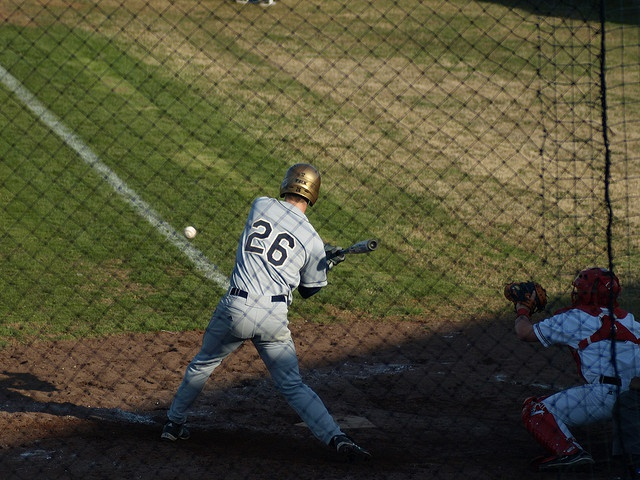Describe the objects in this image and their specific colors. I can see people in gray, black, darkgray, and lightgray tones, people in gray, black, blue, and navy tones, baseball glove in gray, black, maroon, and darkgreen tones, baseball bat in gray, black, blue, and darkgreen tones, and sports ball in gray, ivory, tan, and darkgray tones in this image. 